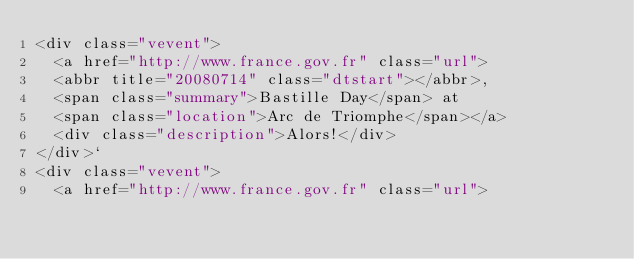Convert code to text. <code><loc_0><loc_0><loc_500><loc_500><_XML_><div class="vevent">
  <a href="http://www.france.gov.fr" class="url">
  <abbr title="20080714" class="dtstart"></abbr>,
  <span class="summary">Bastille Day</span> at
  <span class="location">Arc de Triomphe</span></a>
  <div class="description">Alors!</div>
</div>`
<div class="vevent">
  <a href="http://www.france.gov.fr" class="url"></code> 